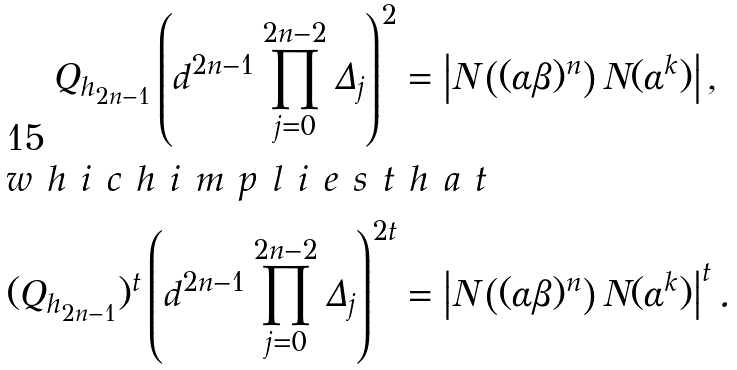Convert formula to latex. <formula><loc_0><loc_0><loc_500><loc_500>Q _ { h _ { 2 n - 1 } } \left ( d ^ { 2 n - 1 } \prod _ { j = 0 } ^ { 2 n - 2 } \Delta _ { j } \right ) ^ { 2 } & = \left | N \left ( ( \alpha \beta ) ^ { n } \right ) N ( \alpha ^ { k } ) \right | , \\ \intertext { w h i c h i m p l i e s t h a t } ( Q _ { h _ { 2 n - 1 } } ) ^ { t } \left ( d ^ { 2 n - 1 } \prod _ { j = 0 } ^ { 2 n - 2 } \Delta _ { j } \right ) ^ { 2 t } & = \left | N \left ( ( \alpha \beta ) ^ { n } \right ) N ( \alpha ^ { k } ) \right | ^ { t } .</formula> 